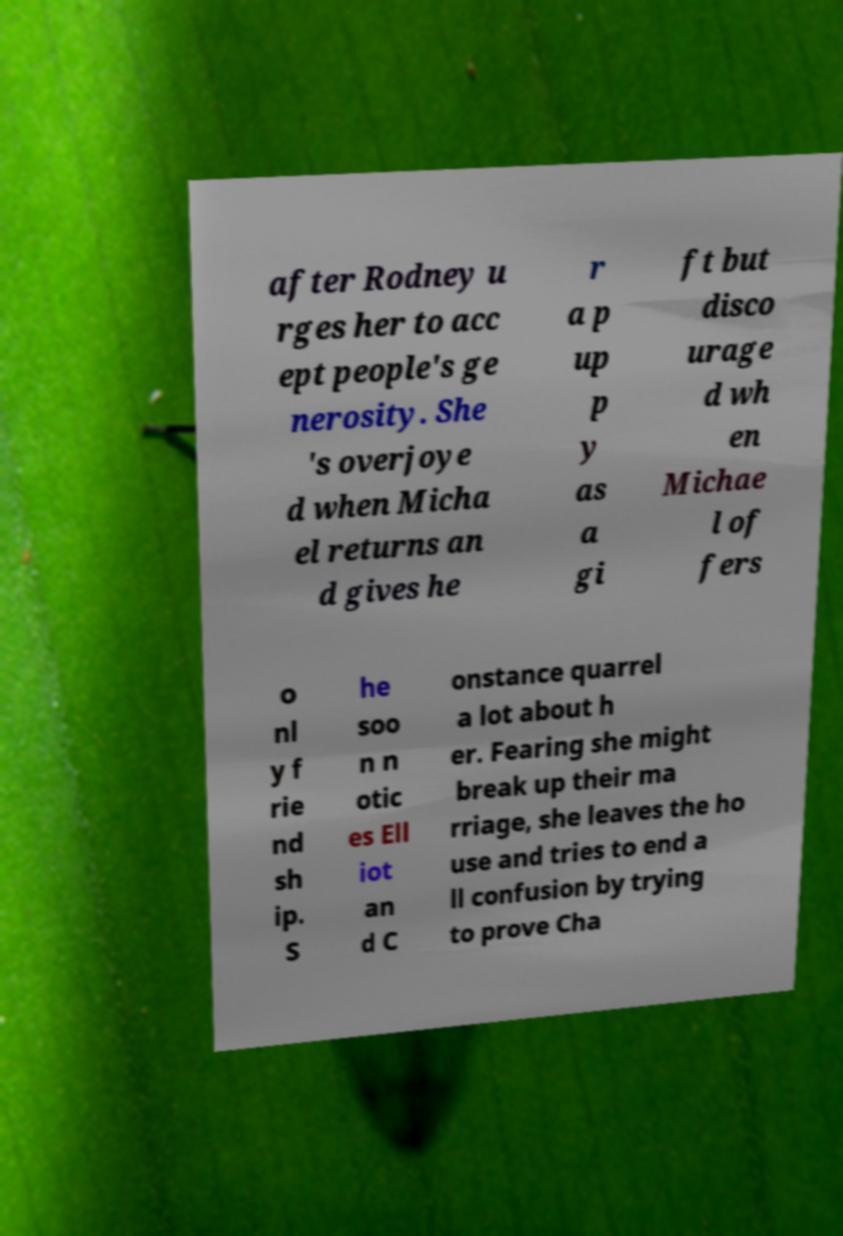Please identify and transcribe the text found in this image. after Rodney u rges her to acc ept people's ge nerosity. She 's overjoye d when Micha el returns an d gives he r a p up p y as a gi ft but disco urage d wh en Michae l of fers o nl y f rie nd sh ip. S he soo n n otic es Ell iot an d C onstance quarrel a lot about h er. Fearing she might break up their ma rriage, she leaves the ho use and tries to end a ll confusion by trying to prove Cha 